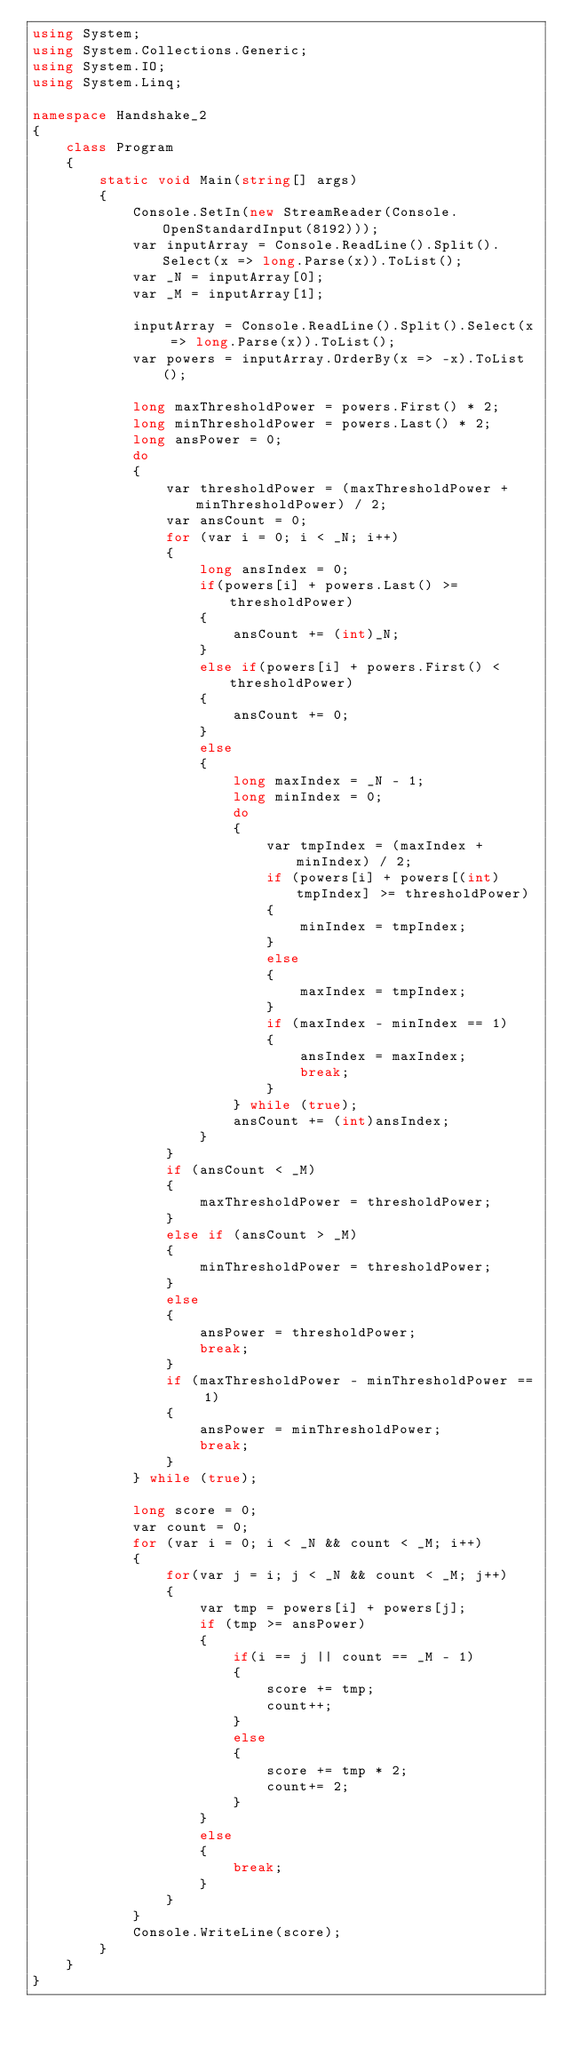<code> <loc_0><loc_0><loc_500><loc_500><_C#_>using System;
using System.Collections.Generic;
using System.IO;
using System.Linq;

namespace Handshake_2
{
    class Program
    {
        static void Main(string[] args)
        {
            Console.SetIn(new StreamReader(Console.OpenStandardInput(8192)));
            var inputArray = Console.ReadLine().Split().Select(x => long.Parse(x)).ToList();
            var _N = inputArray[0];
            var _M = inputArray[1];

            inputArray = Console.ReadLine().Split().Select(x => long.Parse(x)).ToList();
            var powers = inputArray.OrderBy(x => -x).ToList();

            long maxThresholdPower = powers.First() * 2;
            long minThresholdPower = powers.Last() * 2;
            long ansPower = 0;
            do
            {
                var thresholdPower = (maxThresholdPower + minThresholdPower) / 2;
                var ansCount = 0;
                for (var i = 0; i < _N; i++)
                {
                    long ansIndex = 0;
                    if(powers[i] + powers.Last() >= thresholdPower)
                    {
                        ansCount += (int)_N;
                    }
                    else if(powers[i] + powers.First() < thresholdPower)
                    {
                        ansCount += 0;
                    }
                    else
                    {
                        long maxIndex = _N - 1;
                        long minIndex = 0;
                        do
                        {
                            var tmpIndex = (maxIndex + minIndex) / 2;
                            if (powers[i] + powers[(int)tmpIndex] >= thresholdPower)
                            {
                                minIndex = tmpIndex;
                            }
                            else
                            {
                                maxIndex = tmpIndex;
                            }
                            if (maxIndex - minIndex == 1)
                            {
                                ansIndex = maxIndex;
                                break;
                            }
                        } while (true);
                        ansCount += (int)ansIndex;
                    }
                }
                if (ansCount < _M)
                {
                    maxThresholdPower = thresholdPower;
                }
                else if (ansCount > _M)
                {
                    minThresholdPower = thresholdPower;
                }
                else
                {
                    ansPower = thresholdPower;
                    break;
                }
                if (maxThresholdPower - minThresholdPower == 1)
                {
                    ansPower = minThresholdPower;
                    break;
                }
            } while (true);

            long score = 0;
            var count = 0;
            for (var i = 0; i < _N && count < _M; i++)
            {
                for(var j = i; j < _N && count < _M; j++)
                {
                    var tmp = powers[i] + powers[j];
                    if (tmp >= ansPower)
                    {
                        if(i == j || count == _M - 1)
                        {
                            score += tmp;
                            count++;
                        }
                        else
                        {
                            score += tmp * 2;
                            count+= 2;
                        }
                    }
                    else
                    {
                        break;
                    }
                }
            }
            Console.WriteLine(score);
        }
    }
}
</code> 